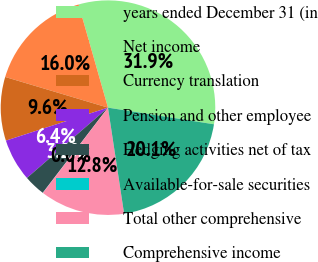<chart> <loc_0><loc_0><loc_500><loc_500><pie_chart><fcel>years ended December 31 (in<fcel>Net income<fcel>Currency translation<fcel>Pension and other employee<fcel>Hedging activities net of tax<fcel>Available-for-sale securities<fcel>Total other comprehensive<fcel>Comprehensive income<nl><fcel>31.9%<fcel>15.96%<fcel>9.59%<fcel>6.4%<fcel>3.22%<fcel>0.03%<fcel>12.78%<fcel>20.12%<nl></chart> 